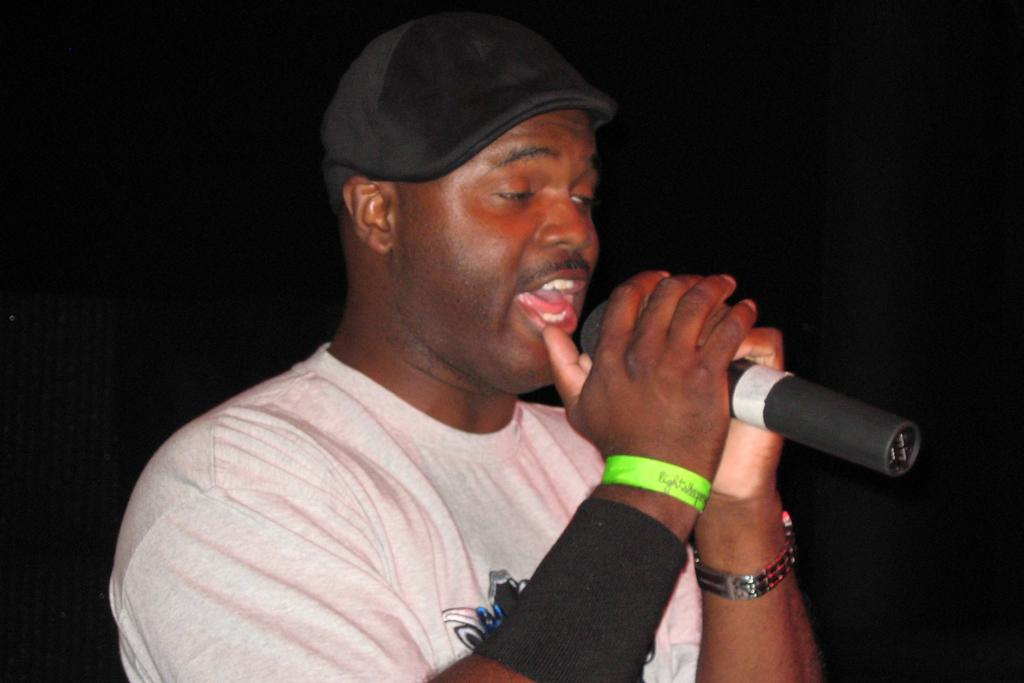Who is the main subject in the image? There is a man in the image. What is the man wearing on his head? The man is wearing a black hat. What type of shirt is the man wearing? The man is wearing a white T-shirt. What is the man doing in the image? The man is talking on a microphone. What type of art is the man creating in the image? There is no indication in the image that the man is creating any art. 